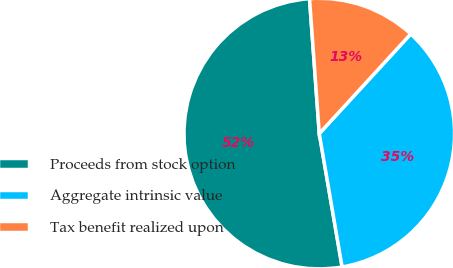Convert chart to OTSL. <chart><loc_0><loc_0><loc_500><loc_500><pie_chart><fcel>Proceeds from stock option<fcel>Aggregate intrinsic value<fcel>Tax benefit realized upon<nl><fcel>51.55%<fcel>35.48%<fcel>12.97%<nl></chart> 